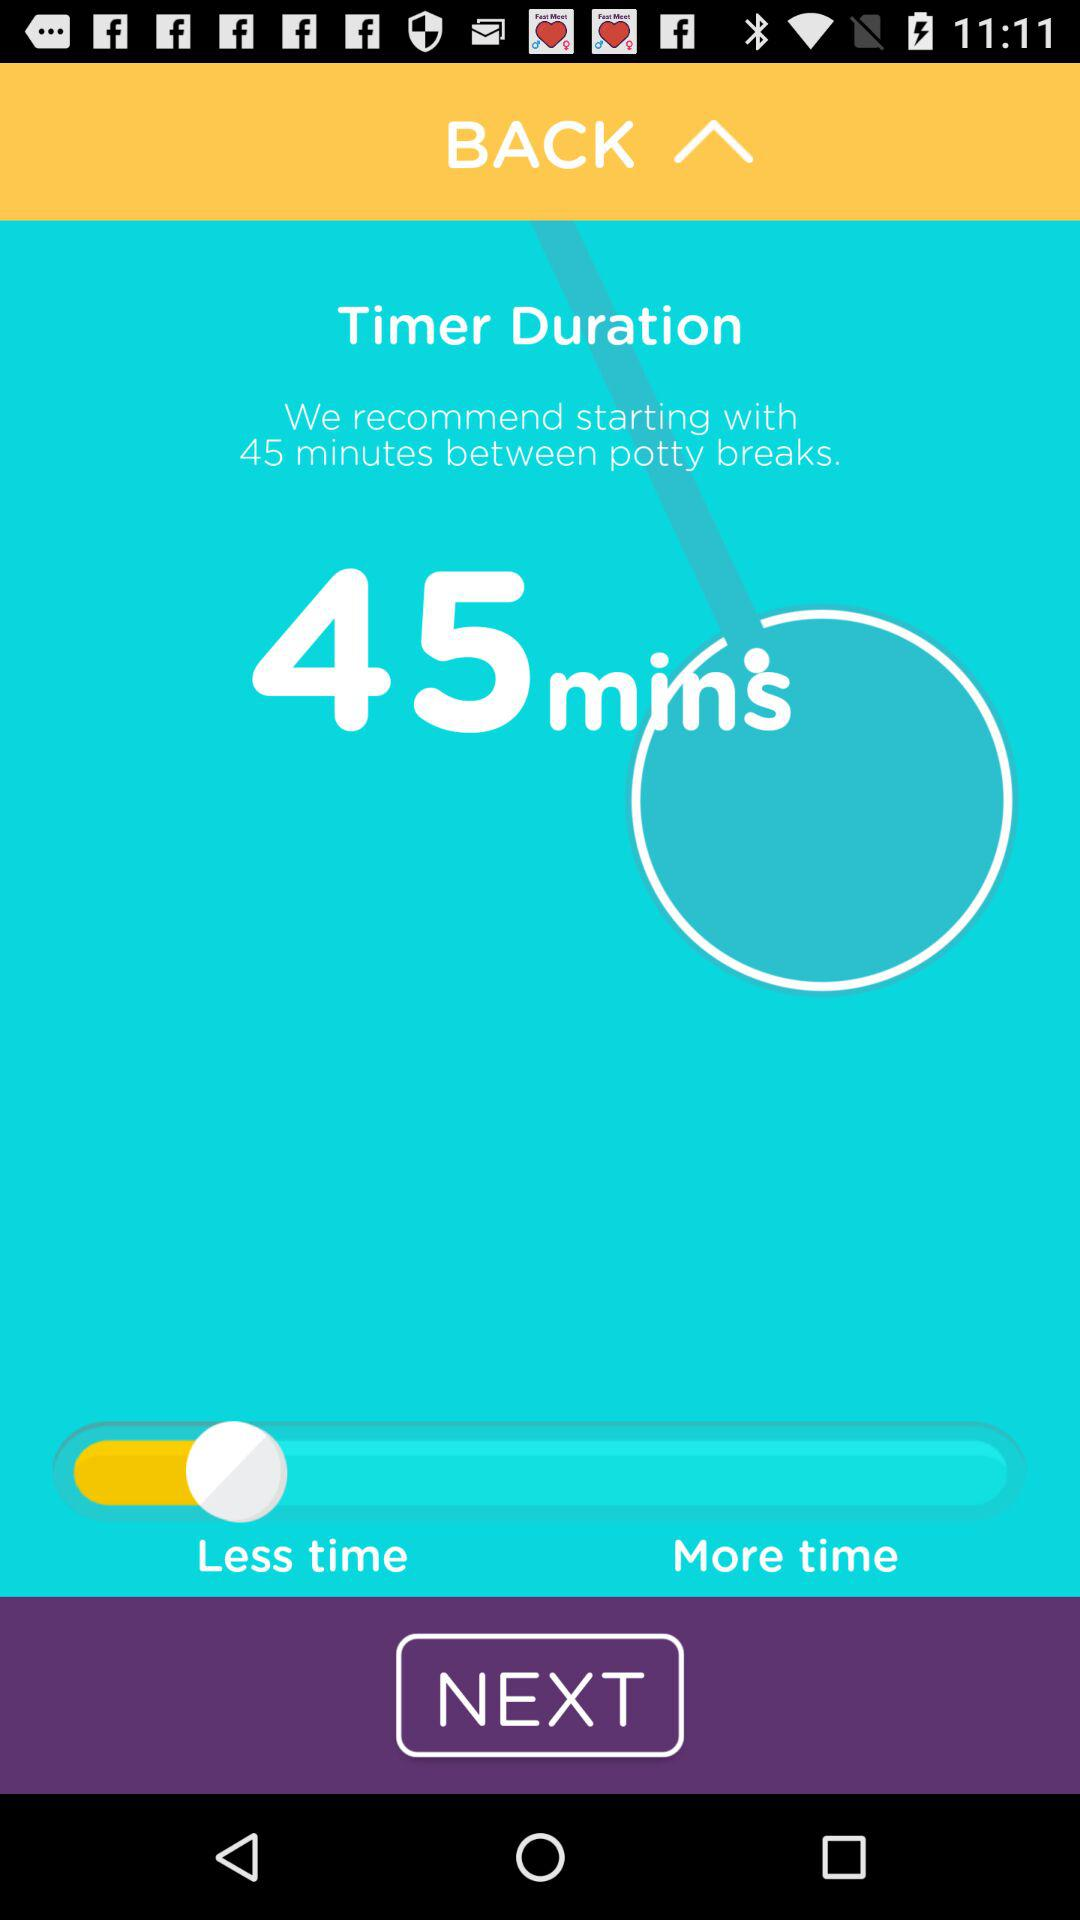How many minutes is the suggested potty break interval?
Answer the question using a single word or phrase. 45 